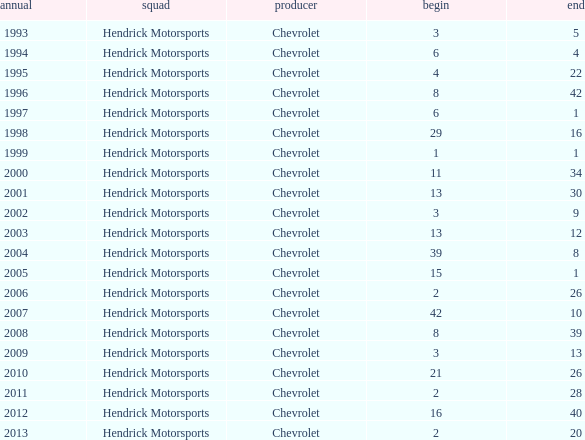Which team had a start of 8 in years under 2008? Hendrick Motorsports. 